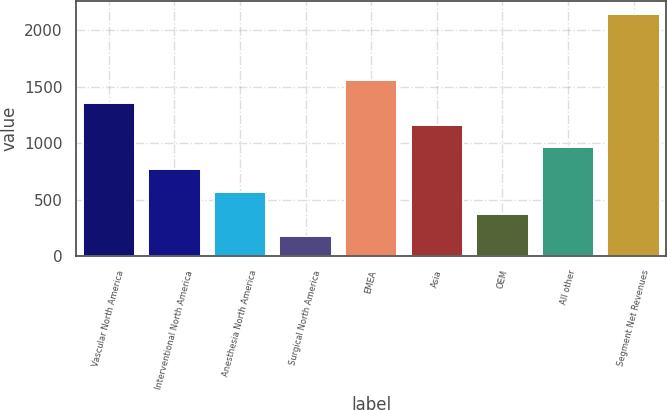<chart> <loc_0><loc_0><loc_500><loc_500><bar_chart><fcel>Vascular North America<fcel>Interventional North America<fcel>Anesthesia North America<fcel>Surgical North America<fcel>EMEA<fcel>Asia<fcel>OEM<fcel>All other<fcel>Segment Net Revenues<nl><fcel>1357.86<fcel>766.53<fcel>569.42<fcel>175.2<fcel>1554.97<fcel>1160.75<fcel>372.31<fcel>963.64<fcel>2146.3<nl></chart> 